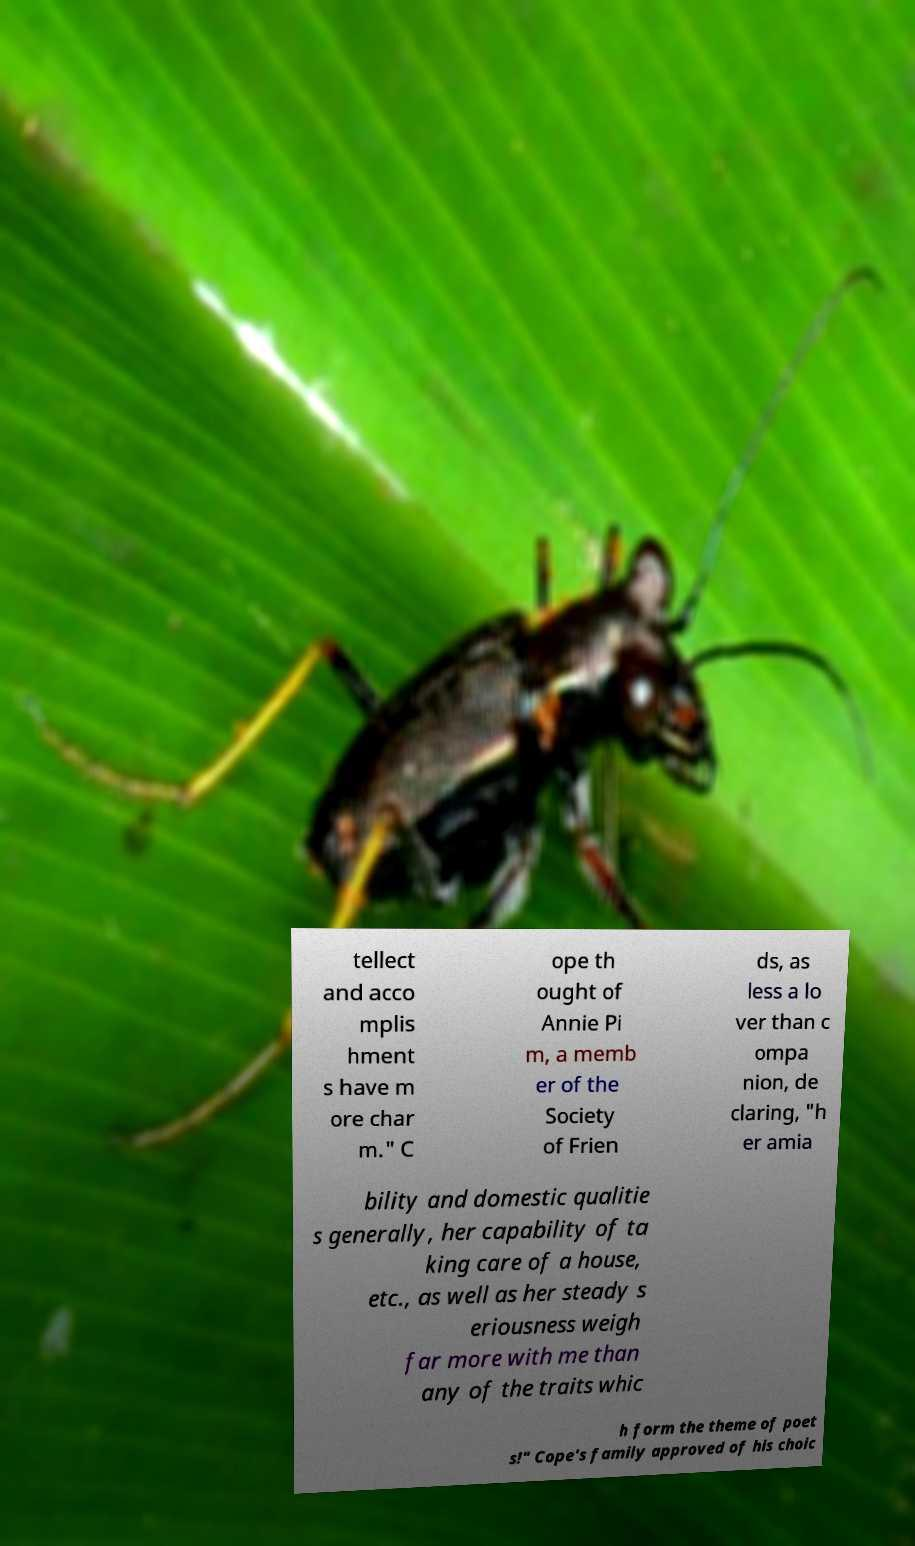Please identify and transcribe the text found in this image. tellect and acco mplis hment s have m ore char m." C ope th ought of Annie Pi m, a memb er of the Society of Frien ds, as less a lo ver than c ompa nion, de claring, "h er amia bility and domestic qualitie s generally, her capability of ta king care of a house, etc., as well as her steady s eriousness weigh far more with me than any of the traits whic h form the theme of poet s!" Cope's family approved of his choic 